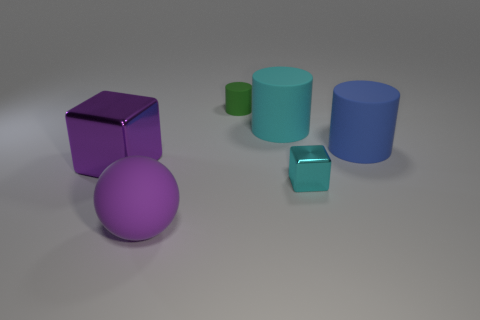There is a cyan object on the right side of the cyan object that is behind the metal cube on the left side of the cyan block; what is its size?
Your answer should be very brief. Small. There is a object that is both left of the cyan rubber object and behind the blue rubber thing; what is its shape?
Provide a short and direct response. Cylinder. Is the number of cyan metallic things that are behind the green rubber cylinder the same as the number of large matte things that are in front of the big purple matte object?
Your answer should be very brief. Yes. Is there a large gray block made of the same material as the small green cylinder?
Make the answer very short. No. Is the material of the large thing behind the blue matte cylinder the same as the purple cube?
Offer a very short reply. No. There is a rubber thing that is both left of the big cyan cylinder and behind the cyan metallic thing; what is its size?
Keep it short and to the point. Small. What is the color of the large metallic object?
Provide a short and direct response. Purple. What number of large red matte things are there?
Provide a succinct answer. 0. What number of metal cubes have the same color as the big ball?
Provide a succinct answer. 1. Do the cyan thing behind the big blue matte cylinder and the small thing behind the big blue object have the same shape?
Provide a succinct answer. Yes. 